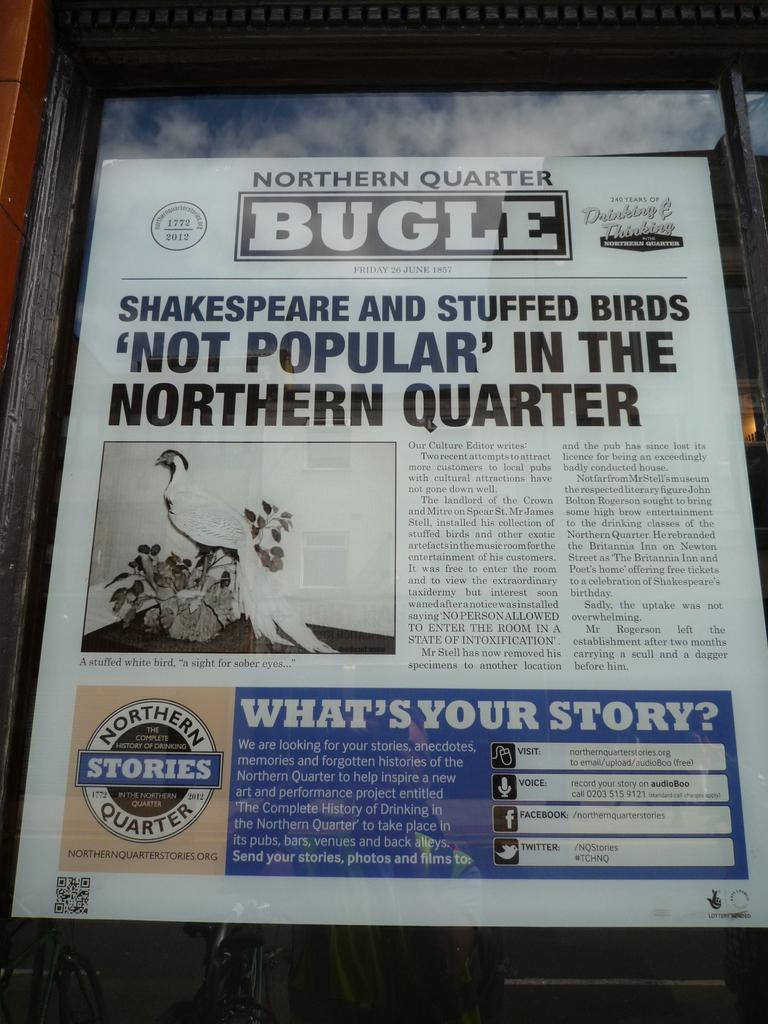<image>
Summarize the visual content of the image. The Northern Quarter Bugle from June 26 of 1857 has a headline about stuffed birds. 